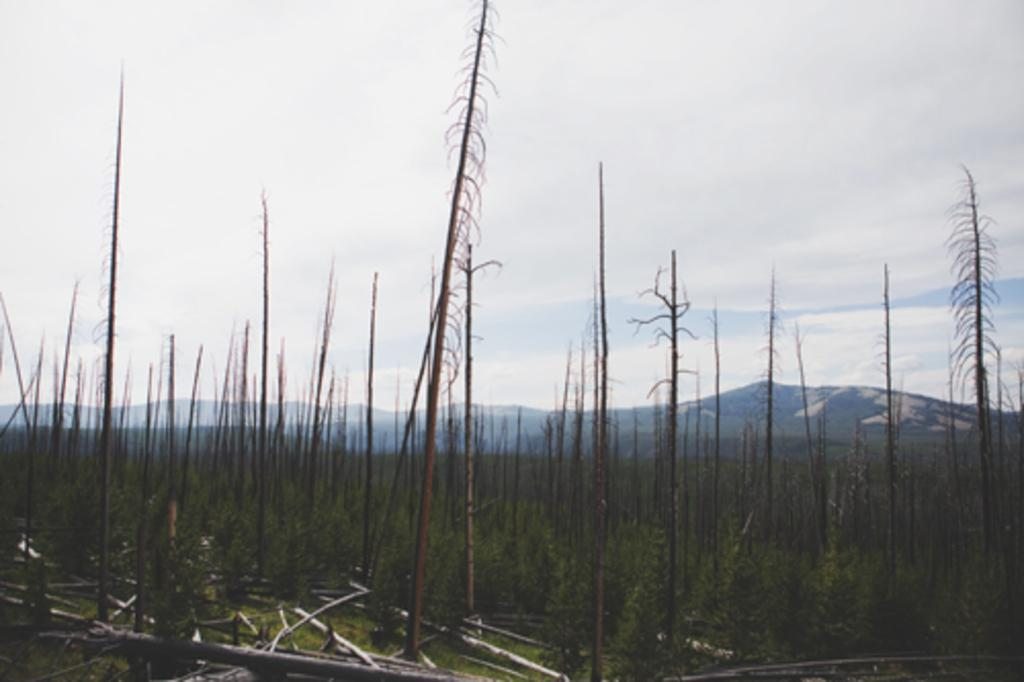What type of vegetation is present in the image? There are trees and plants in the image. What color are the trees and plants? The trees and plants are green. What can be seen in the background of the image? There are mountains in the background of the image. What is the color of the sky in the image? The sky is white in color. What type of leather is visible on the front of the trees in the image? There is no leather present in the image, as it features trees and plants with no leather components. 